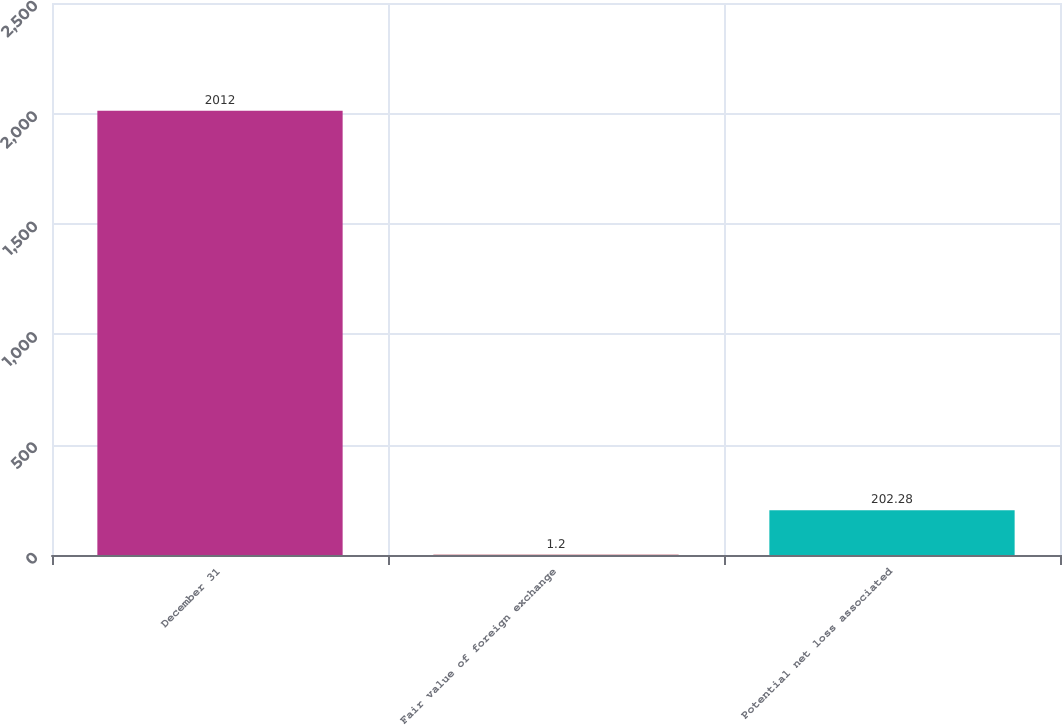Convert chart. <chart><loc_0><loc_0><loc_500><loc_500><bar_chart><fcel>December 31<fcel>Fair value of foreign exchange<fcel>Potential net loss associated<nl><fcel>2012<fcel>1.2<fcel>202.28<nl></chart> 